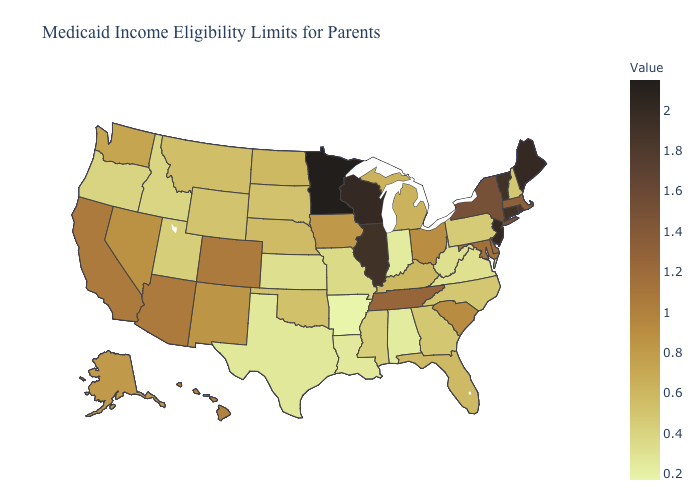Which states have the lowest value in the Northeast?
Short answer required. Pennsylvania. Which states have the highest value in the USA?
Concise answer only. Minnesota. Among the states that border Massachusetts , which have the lowest value?
Quick response, please. New Hampshire. Does Indiana have the lowest value in the MidWest?
Give a very brief answer. Yes. 